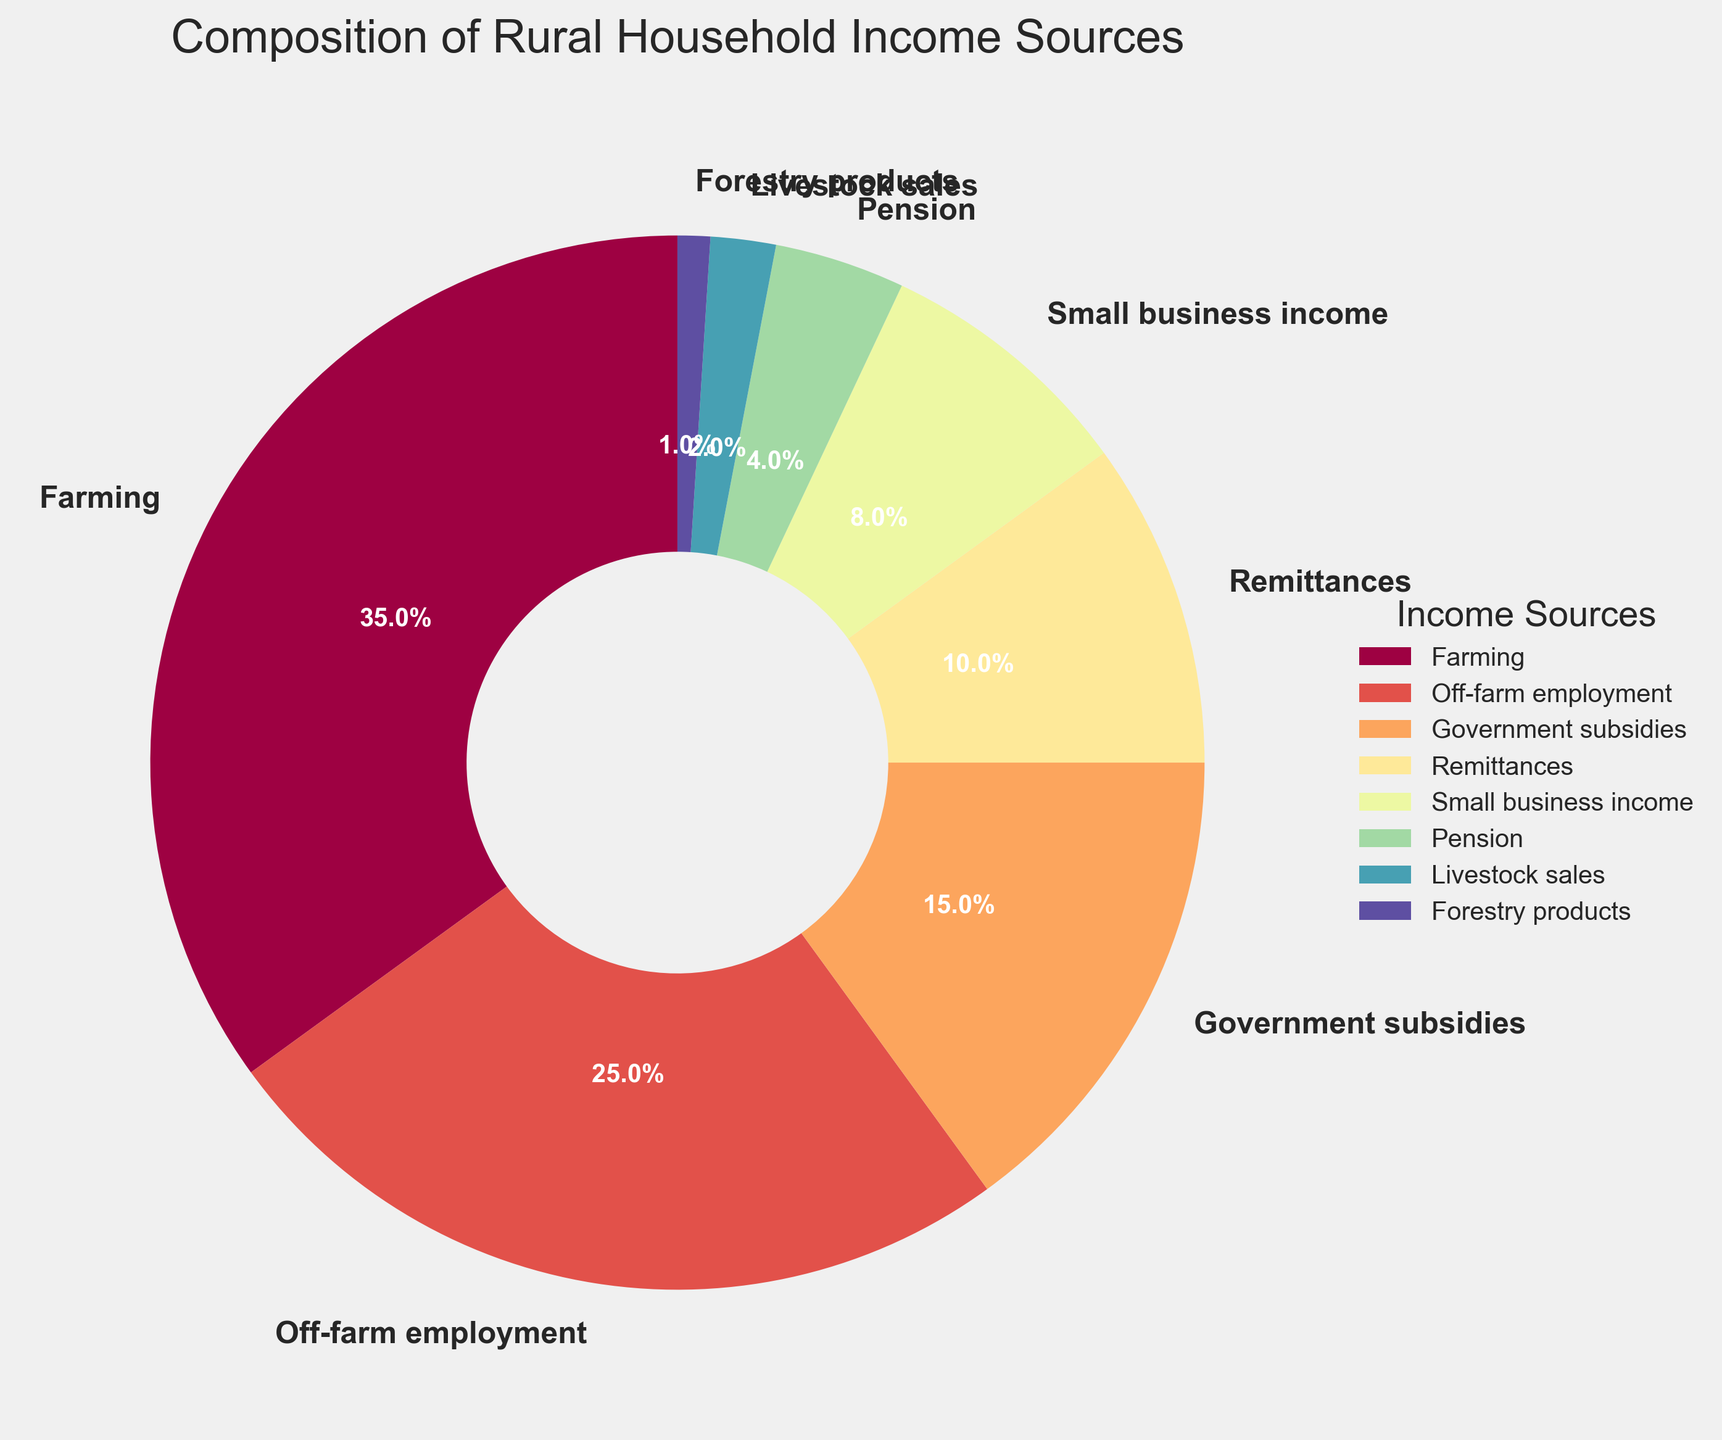Which two income sources have the closest percentages? The pie chart shows the following percentages: Farming (35%), Off-farm employment (25%), Government subsidies (15%), Remittances (10%), Small business income (8%), Pension (4%), Livestock sales (2%), and Forestry products (1%). The closest percentages are Government subsidies (15%) and Remittances (10%), having a difference of only 5%.
Answer: Government subsidies and Remittances What is the total percentage of income derived from non-agricultural sources? Non-agricultural sources include Off-farm employment (25%), Government subsidies (15%), Remittances (10%), Small business income (8%), Pension (4%), and Forestry products (1%). Adding these values: 25 + 15 + 10 + 8 + 4 + 1 = 63%.
Answer: 63% Which income source contributes the least to rural household income? Based on the pie chart, the smallest segment is for Forestry products, which is 1%.
Answer: Forestry products How much more does Farming contribute to household income compared to Small business income? Farming contributes 35% while Small business income contributes 8%. The difference is 35 - 8 = 27%.
Answer: 27% Which source of income is greater: Off-farm employment or the combined income of Small business income and Remittances? Off-farm employment contributes 25%. The combined income of Small business income and Remittances is 8% + 10% = 18%. Since 25% is greater than 18%, Off-farm employment is greater.
Answer: Off-farm employment What proportion of the pie chart does Pension and Livestock sales together represent? Pension contributes 4% and Livestock sales contribute 2%. Adding these values: 4 + 2 = 6%.
Answer: 6% Which color represents the Government subsidies section in the pie chart? The pie chart uses different colors for each segment. Based on the arrangement and the legend, we can identify the specific color for Government subsidies.
Answer: Varies (color strictly from visual inspection which corresponds in the chart legend) Is the percentage of income from Remittances greater than from Pension and Livestock sales combined? Remittances contribute 10%, while Pension and Livestock sales combined are 4% + 2% = 6%. Since 10% is greater than 6%, the answer is yes.
Answer: Yes What is the difference in income contribution between Off-farm employment and Government subsidies? Off-farm employment contributes 25%, and Government subsidies contribute 15%. The difference is 25 - 15 = 10%.
Answer: 10% 